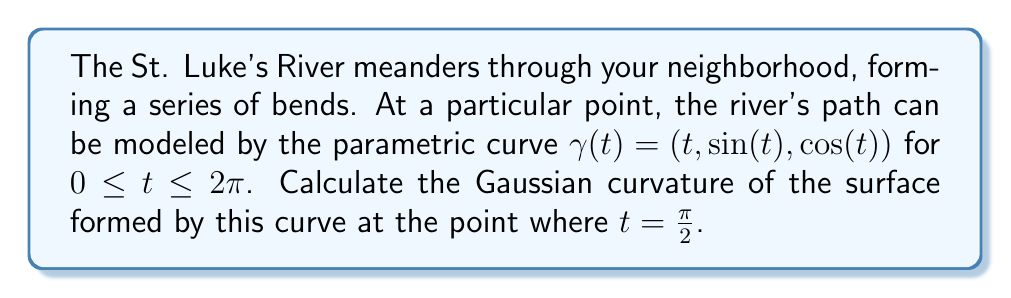Can you solve this math problem? To calculate the Gaussian curvature of the surface formed by the river's path, we'll follow these steps:

1) First, we need to find the first and second fundamental forms of the surface. For a parametric curve $\gamma(t) = (x(t), y(t), z(t))$, we can consider it as a surface with parameters $u$ and $v$, where $u = t$ and $v$ is a parameter along the normal direction.

2) The tangent vector to the curve is:
   $$\gamma'(t) = (1, \cos(t), -\sin(t))$$

3) A unit normal vector to the curve is:
   $$N(t) = \frac{(-\cos(t), \sin(t), 1)}{\sqrt{2}}$$

4) Now we can define our surface as:
   $$S(u,v) = \gamma(u) + vN(u)$$

5) The partial derivatives are:
   $$S_u = (1, \cos(u), -\sin(u)) + v(-\sin(u), \cos(u), 0)/\sqrt{2}$$
   $$S_v = (-\cos(u), \sin(u), 1)/\sqrt{2}$$

6) The coefficients of the first fundamental form are:
   $$E = S_u \cdot S_u = 1 + v^2/2$$
   $$F = S_u \cdot S_v = 0$$
   $$G = S_v \cdot S_v = 1$$

7) For the second fundamental form, we need:
   $$S_{uu} = (0, -\sin(u), -\cos(u)) + v(-\cos(u), -\sin(u), 0)/\sqrt{2}$$
   $$S_{uv} = (-\sin(u), \cos(u), 0)/\sqrt{2}$$
   $$S_{vv} = (0, 0, 0)$$

8) The coefficients of the second fundamental form are:
   $$L = S_{uu} \cdot N = -1/\sqrt{2}$$
   $$M = S_{uv} \cdot N = 0$$
   $$N = S_{vv} \cdot N = 0$$

9) The Gaussian curvature is given by:
   $$K = \frac{LN - M^2}{EG - F^2} = \frac{0 - 0}{(1 + v^2/2)(1) - 0^2} = 0$$

10) This result is independent of $u$ and $v$, so it holds for all points on the surface, including the point where $t = \frac{\pi}{2}$.
Answer: The Gaussian curvature of the surface formed by the river's path at $t = \frac{\pi}{2}$ is $K = 0$. 